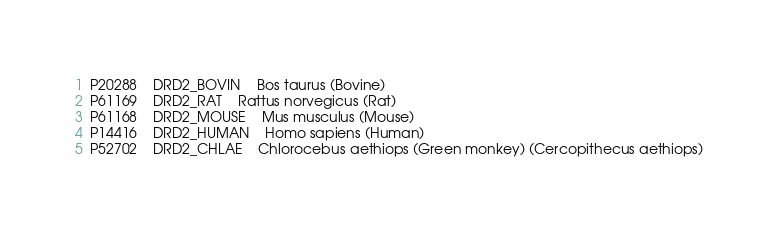<code> <loc_0><loc_0><loc_500><loc_500><_SQL_>P20288	DRD2_BOVIN	Bos taurus (Bovine)
P61169	DRD2_RAT	Rattus norvegicus (Rat)
P61168	DRD2_MOUSE	Mus musculus (Mouse)
P14416	DRD2_HUMAN	Homo sapiens (Human)
P52702	DRD2_CHLAE	Chlorocebus aethiops (Green monkey) (Cercopithecus aethiops)
</code> 